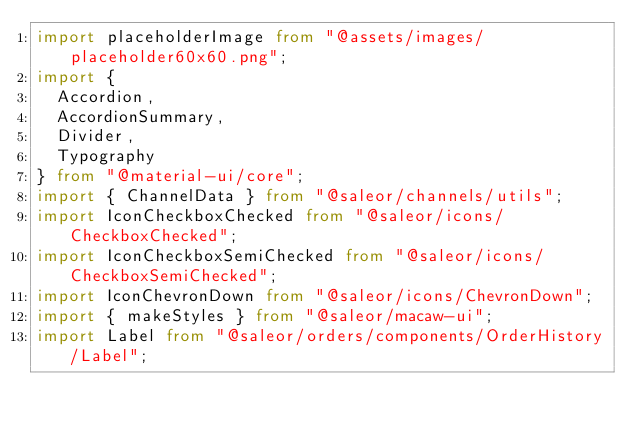<code> <loc_0><loc_0><loc_500><loc_500><_TypeScript_>import placeholderImage from "@assets/images/placeholder60x60.png";
import {
  Accordion,
  AccordionSummary,
  Divider,
  Typography
} from "@material-ui/core";
import { ChannelData } from "@saleor/channels/utils";
import IconCheckboxChecked from "@saleor/icons/CheckboxChecked";
import IconCheckboxSemiChecked from "@saleor/icons/CheckboxSemiChecked";
import IconChevronDown from "@saleor/icons/ChevronDown";
import { makeStyles } from "@saleor/macaw-ui";
import Label from "@saleor/orders/components/OrderHistory/Label";</code> 